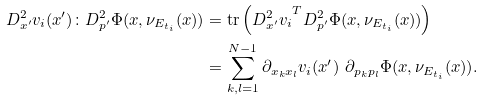<formula> <loc_0><loc_0><loc_500><loc_500>D ^ { 2 } _ { x ^ { \prime } } v _ { i } ( { x } ^ { \prime } ) \colon D ^ { 2 } _ { p ^ { \prime } } \Phi ( { x } , \nu _ { E _ { t _ { i } } } ( { x } ) ) & = \text {tr} \left ( { D ^ { 2 } _ { x ^ { \prime } } v _ { i } } ^ { T } D ^ { 2 } _ { p ^ { \prime } } \Phi ( { x } , \nu _ { E _ { t _ { i } } } ( { x } ) ) \right ) \\ & = \sum _ { k , l = 1 } ^ { N - 1 } \partial _ { x _ { k } x _ { l } } v _ { i } ( { x } ^ { \prime } ) \ \partial _ { p _ { k } p _ { l } } \Phi ( { x } , \nu _ { E _ { t _ { i } } } ( { x } ) ) .</formula> 